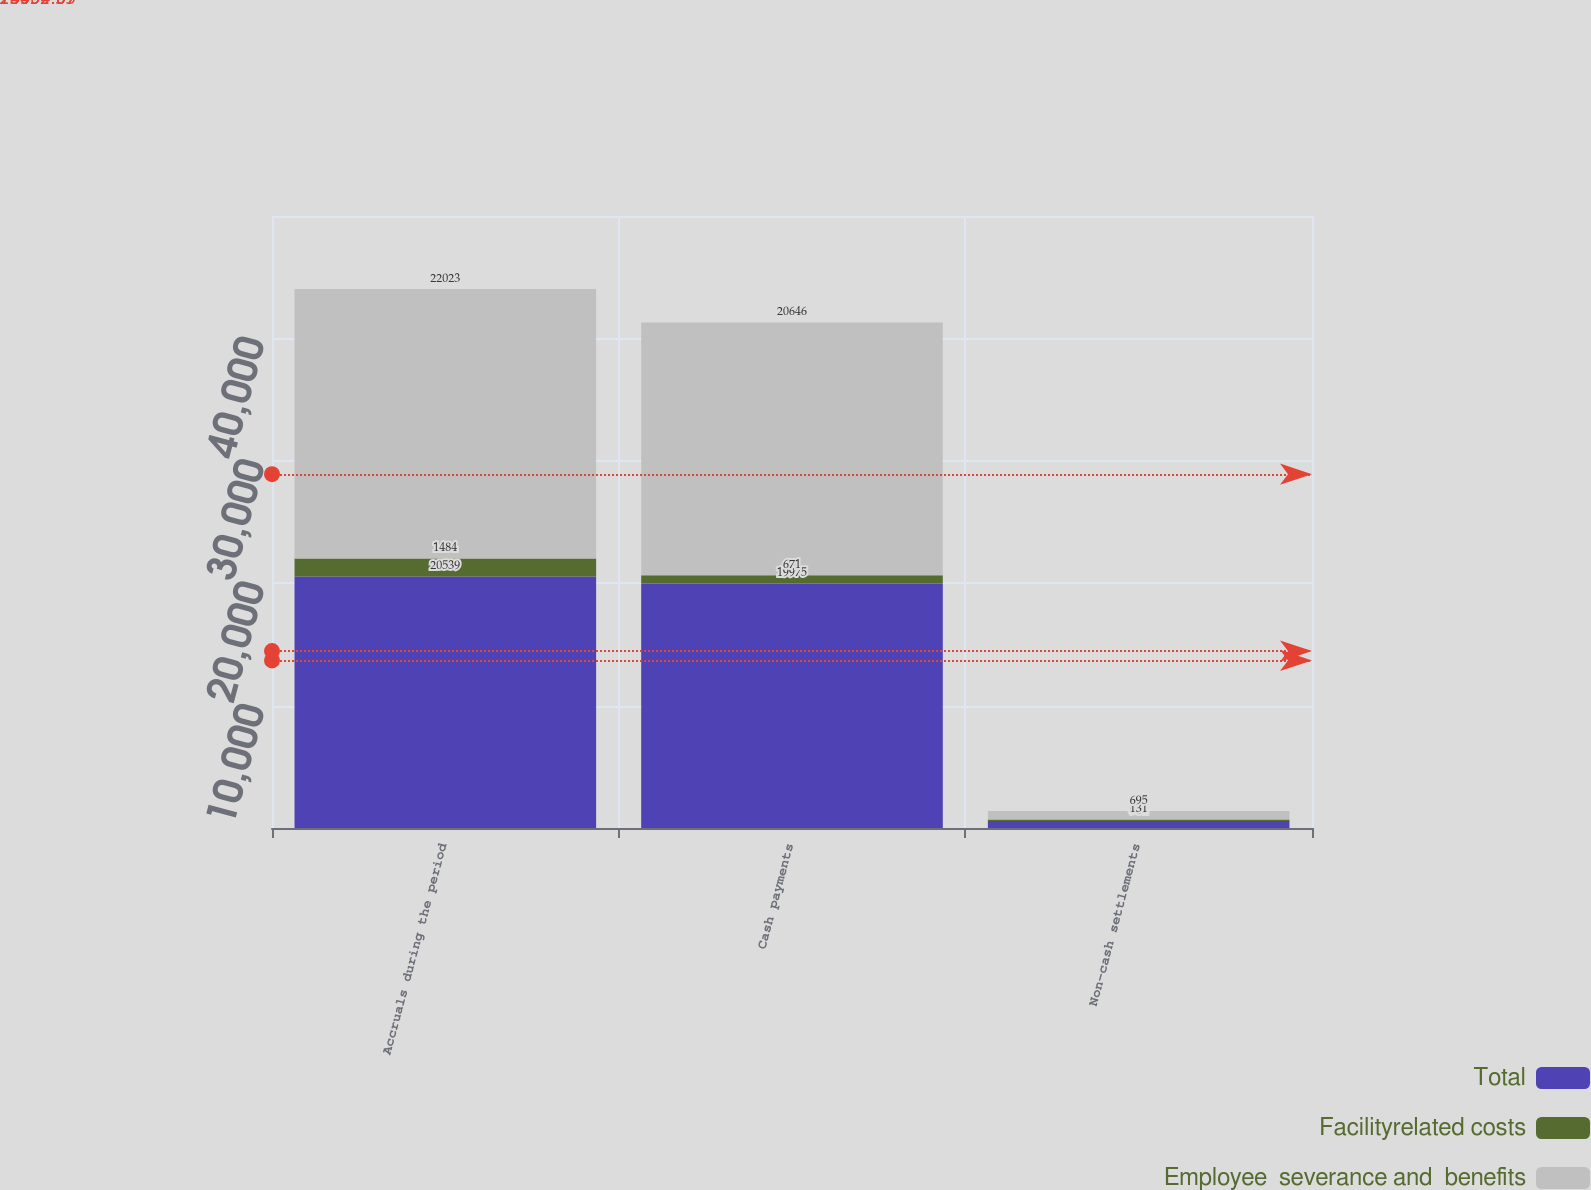Convert chart to OTSL. <chart><loc_0><loc_0><loc_500><loc_500><stacked_bar_chart><ecel><fcel>Accruals during the period<fcel>Cash payments<fcel>Non-cash settlements<nl><fcel>Total<fcel>20539<fcel>19975<fcel>564<nl><fcel>Facilityrelated costs<fcel>1484<fcel>671<fcel>131<nl><fcel>Employee  severance and  benefits<fcel>22023<fcel>20646<fcel>695<nl></chart> 